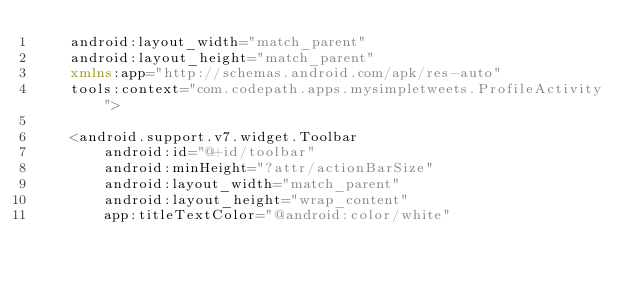Convert code to text. <code><loc_0><loc_0><loc_500><loc_500><_XML_>    android:layout_width="match_parent"
    android:layout_height="match_parent"
    xmlns:app="http://schemas.android.com/apk/res-auto"
    tools:context="com.codepath.apps.mysimpletweets.ProfileActivity">

    <android.support.v7.widget.Toolbar
        android:id="@+id/toolbar"
        android:minHeight="?attr/actionBarSize"
        android:layout_width="match_parent"
        android:layout_height="wrap_content"
        app:titleTextColor="@android:color/white"</code> 